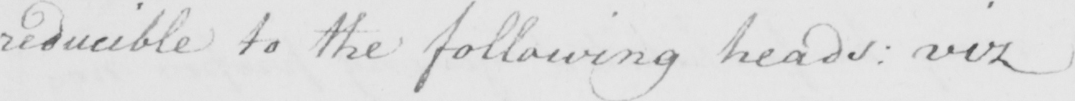Can you read and transcribe this handwriting? reducible to the following heads :  viz 